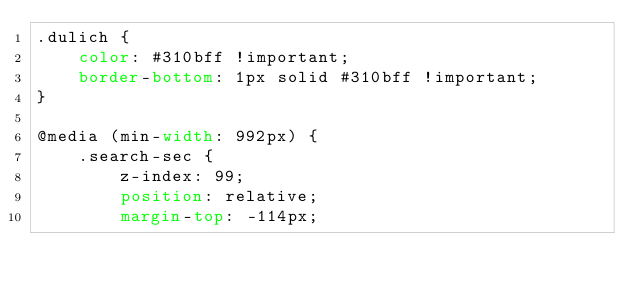<code> <loc_0><loc_0><loc_500><loc_500><_CSS_>.dulich {
    color: #310bff !important;
    border-bottom: 1px solid #310bff !important;
}

@media (min-width: 992px) {
    .search-sec {
        z-index: 99;
        position: relative;
        margin-top: -114px;</code> 